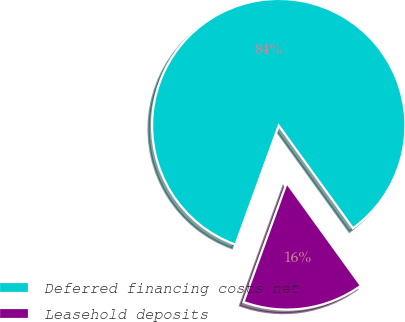Convert chart to OTSL. <chart><loc_0><loc_0><loc_500><loc_500><pie_chart><fcel>Deferred financing costs net<fcel>Leasehold deposits<nl><fcel>84.5%<fcel>15.5%<nl></chart> 